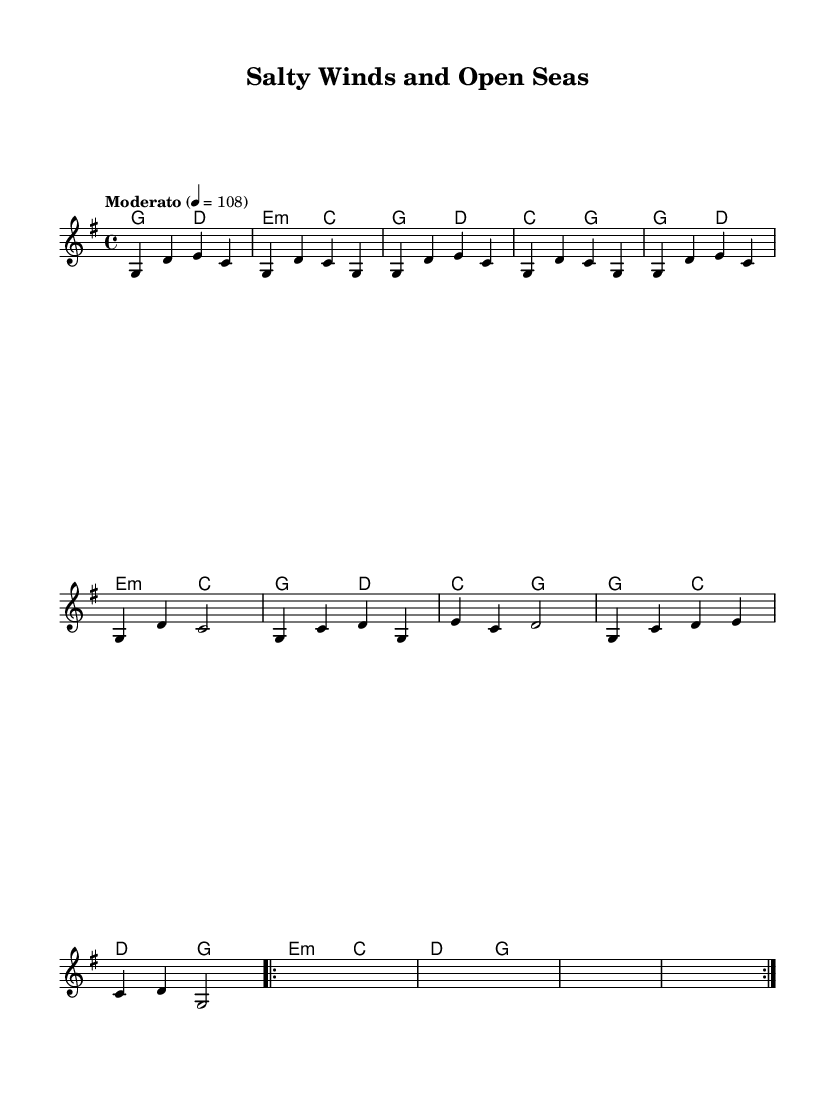What is the key signature of this music? The key signature is G major, which has one sharp (F#) indicated at the beginning of the staff.
Answer: G major What is the time signature of this music? The time signature is 4/4, meaning there are 4 beats in each measure and each quarter note gets one beat.
Answer: 4/4 What is the tempo marking for this piece? The tempo marking "Moderato" indicates a moderate speed, which is typically around 108 beats per minute as indicated on the score.
Answer: Moderato How many measures are there in the chorus? By counting, there are 8 measures in the chorus section, which is indicated by the lyric text and the musical notation.
Answer: 8 What is the first lyric of the verse? The verse starts with the lyric "Raised the anchor, set the sails," which is specified in the lyrics section under the melody.
Answer: Raised the anchor In which section does the "salty winds and open seas" appear? The phrase "salty winds and open seas" is part of the chorus, which is typically where the main theme of the song is repeated.
Answer: Chorus What kind of musical structure is used in this piece? The piece follows a typical verse-chorus structure, where verses alternate with choruses, common in country rock songs.
Answer: Verse-Chorus 